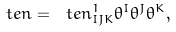Convert formula to latex. <formula><loc_0><loc_0><loc_500><loc_500>\ t e n = \ t e n ^ { 1 } _ { I J K } \theta ^ { I } \theta ^ { J } \theta ^ { K } ,</formula> 